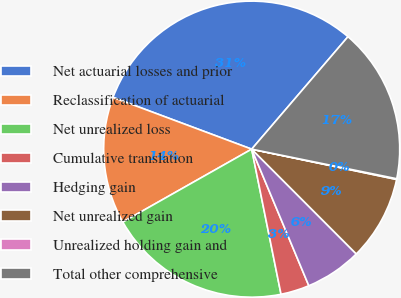Convert chart to OTSL. <chart><loc_0><loc_0><loc_500><loc_500><pie_chart><fcel>Net actuarial losses and prior<fcel>Reclassification of actuarial<fcel>Net unrealized loss<fcel>Cumulative translation<fcel>Hedging gain<fcel>Net unrealized gain<fcel>Unrealized holding gain and<fcel>Total other comprehensive<nl><fcel>30.58%<fcel>13.88%<fcel>19.98%<fcel>3.13%<fcel>6.18%<fcel>9.23%<fcel>0.08%<fcel>16.93%<nl></chart> 